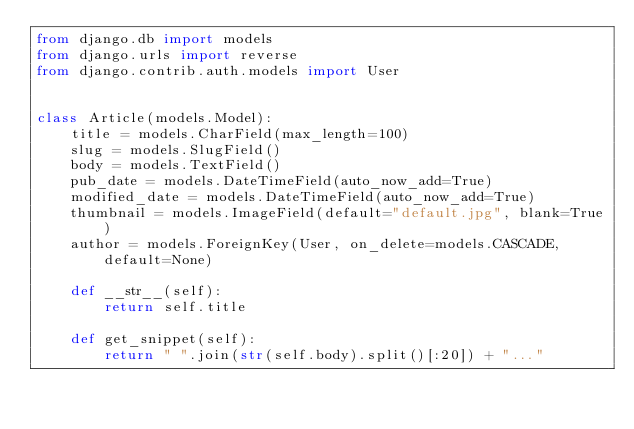<code> <loc_0><loc_0><loc_500><loc_500><_Python_>from django.db import models
from django.urls import reverse
from django.contrib.auth.models import User


class Article(models.Model):
    title = models.CharField(max_length=100)
    slug = models.SlugField()
    body = models.TextField()
    pub_date = models.DateTimeField(auto_now_add=True)
    modified_date = models.DateTimeField(auto_now_add=True)
    thumbnail = models.ImageField(default="default.jpg", blank=True)
    author = models.ForeignKey(User, on_delete=models.CASCADE, default=None)

    def __str__(self):
        return self.title

    def get_snippet(self):
        return " ".join(str(self.body).split()[:20]) + "..."
</code> 